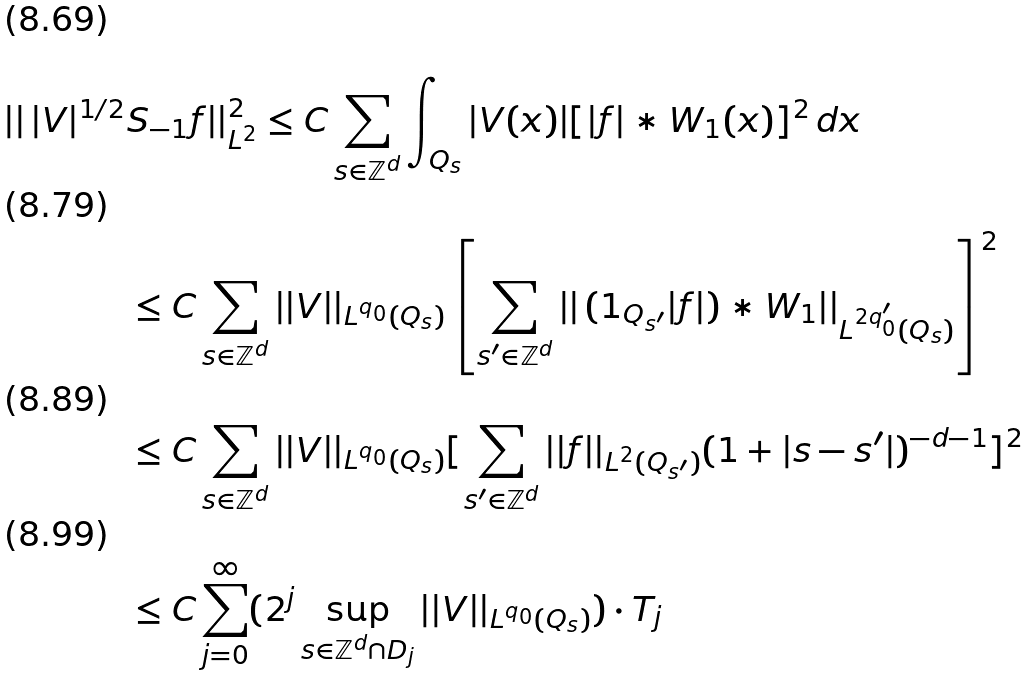Convert formula to latex. <formula><loc_0><loc_0><loc_500><loc_500>| | \, | V | ^ { 1 / 2 } & S _ { - 1 } f | | _ { L ^ { 2 } } ^ { 2 } \leq C \sum _ { s \in \mathbb { Z } ^ { d } } \int _ { Q _ { s } } | V ( x ) | [ | f | \ast W _ { 1 } ( x ) ] ^ { 2 } \, d x \\ & \leq C \sum _ { s \in \mathbb { Z } ^ { d } } | | V | | _ { L ^ { q _ { 0 } } ( Q _ { s } ) } \left [ \sum _ { s ^ { \prime } \in \mathbb { Z } ^ { d } } | | \, ( 1 _ { Q _ { s ^ { \prime } } } | f | ) \ast W _ { 1 } | | _ { L ^ { 2 q _ { 0 } ^ { \prime } } ( Q _ { s } ) } \right ] ^ { 2 } \\ & \leq C \sum _ { s \in \mathbb { Z } ^ { d } } | | V | | _ { L ^ { q _ { 0 } } ( Q _ { s } ) } [ \sum _ { s ^ { \prime } \in \mathbb { Z } ^ { d } } | | f | | _ { L ^ { 2 } ( Q _ { s ^ { \prime } } ) } ( 1 + | s - s ^ { \prime } | ) ^ { - d - 1 } ] ^ { 2 } \\ & \leq C \sum _ { j = 0 } ^ { \infty } ( 2 ^ { j } \sup _ { s \in \mathbb { Z } ^ { d } \cap D _ { j } } | | V | | _ { L ^ { q _ { 0 } } ( Q _ { s } ) } ) \cdot T _ { j }</formula> 